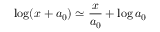Convert formula to latex. <formula><loc_0><loc_0><loc_500><loc_500>\log ( x + a _ { 0 } ) \simeq \frac { x } { a _ { 0 } } + \log a _ { 0 }</formula> 